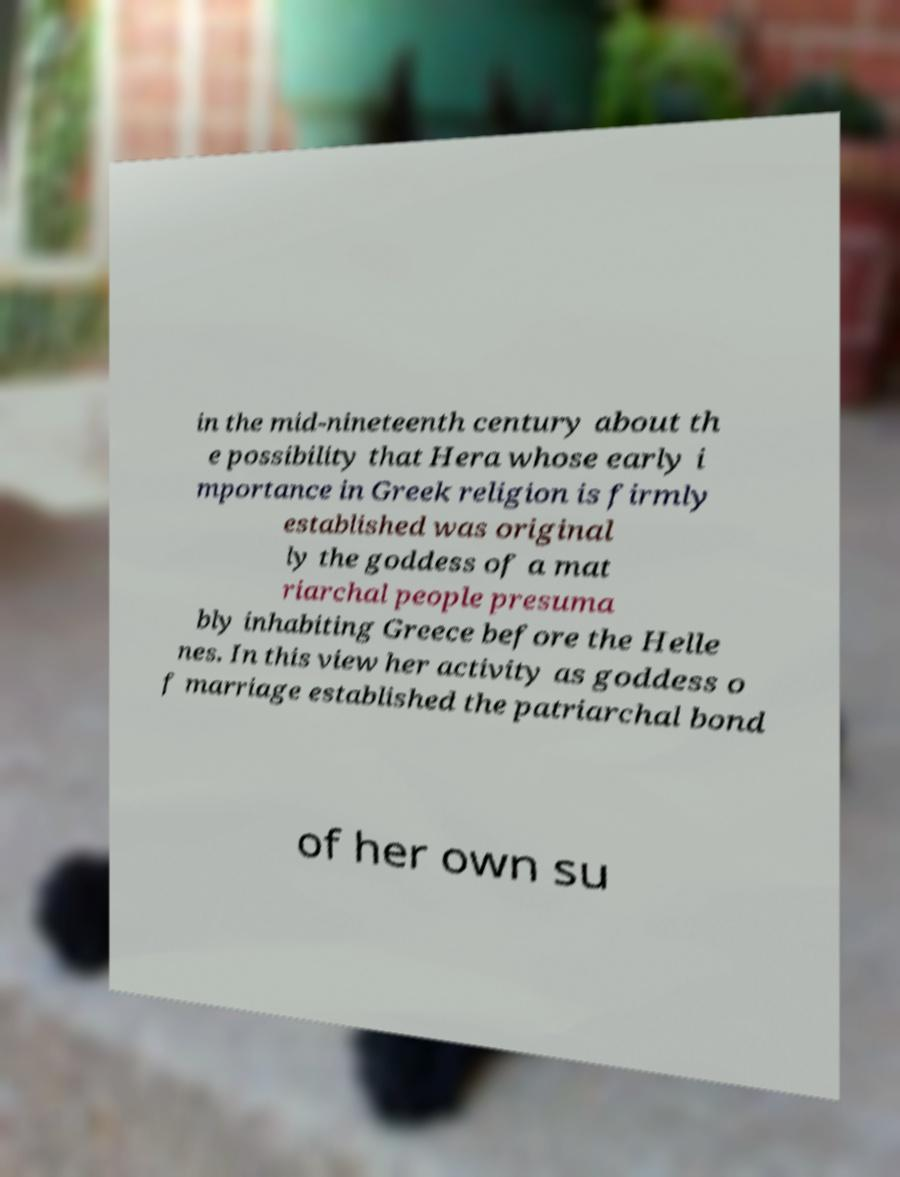Please identify and transcribe the text found in this image. in the mid-nineteenth century about th e possibility that Hera whose early i mportance in Greek religion is firmly established was original ly the goddess of a mat riarchal people presuma bly inhabiting Greece before the Helle nes. In this view her activity as goddess o f marriage established the patriarchal bond of her own su 